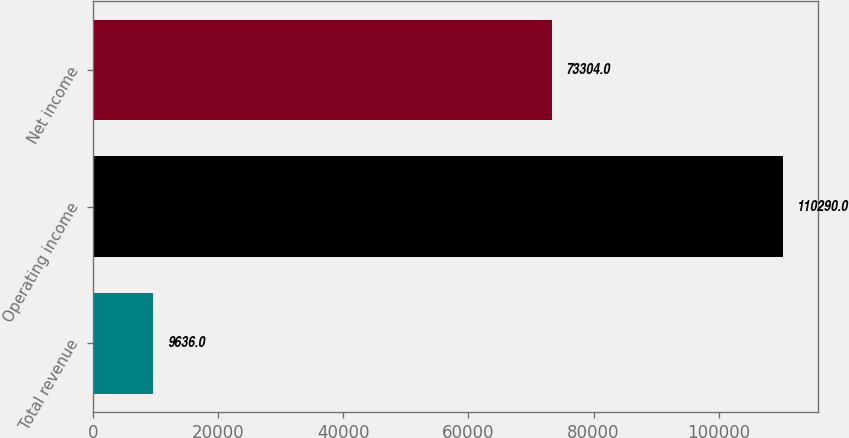Convert chart. <chart><loc_0><loc_0><loc_500><loc_500><bar_chart><fcel>Total revenue<fcel>Operating income<fcel>Net income<nl><fcel>9636<fcel>110290<fcel>73304<nl></chart> 